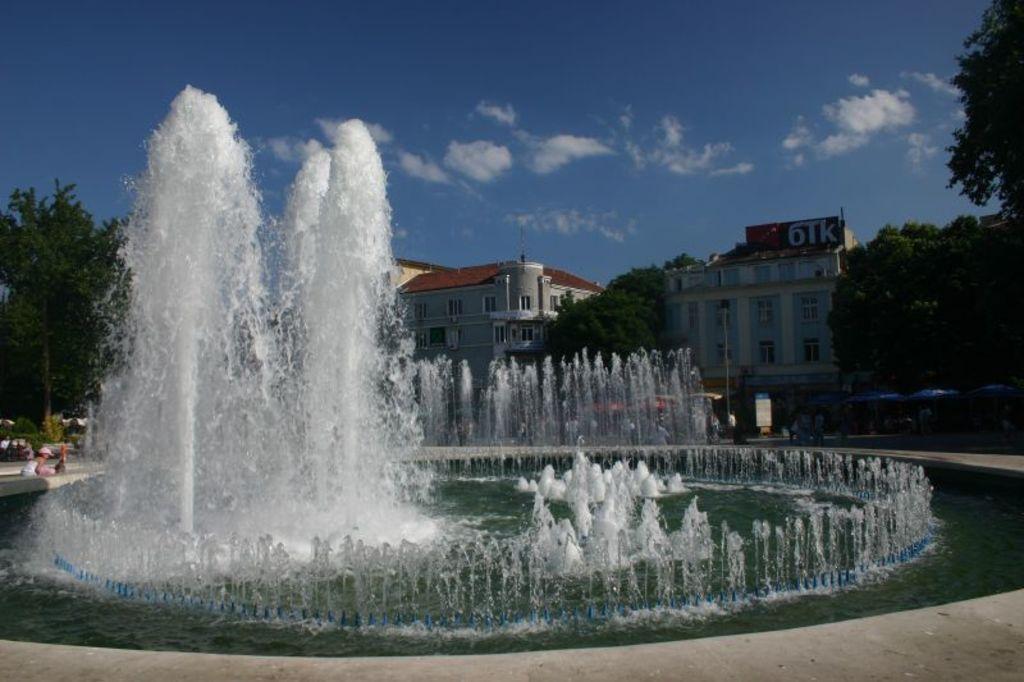In one or two sentences, can you explain what this image depicts? In the middle of the picture, we see the water fountains. We see a woman is sitting beside that. Behind the fountains, we see the people are standing on the road. There are trees, buildings and poles in the background. On the right side, we see the trees and tents in blue color. Beside that, we see a pole and a board in white color with some text written on it. At the top, we see the sky and the clouds. 